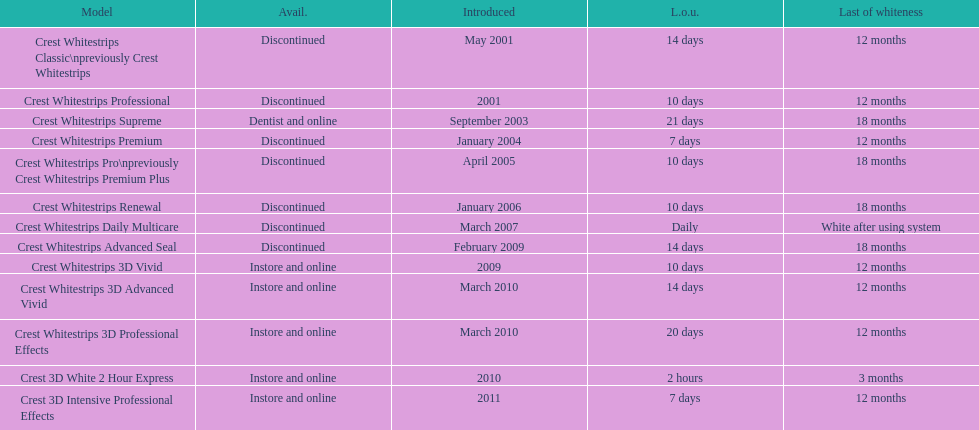Which model exhibits the maximum 'length of utilization' to 'conclusion of whiteness' relationship? Crest Whitestrips Supreme. 